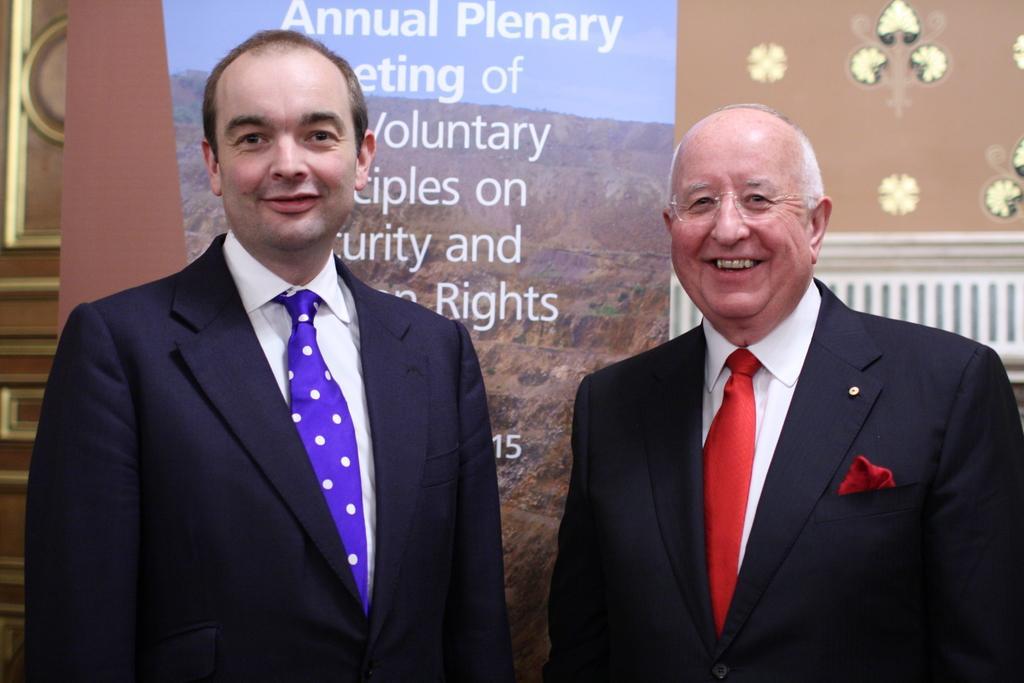Could you give a brief overview of what you see in this image? In this image we can see men standing and smiling. In the background there are advertising and wall. 